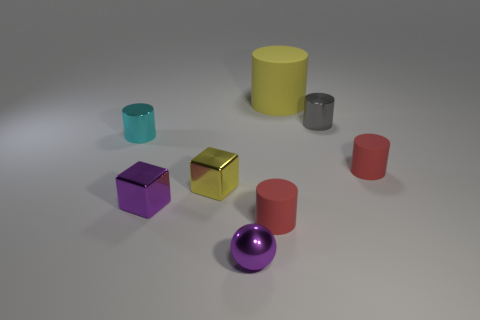There is a tiny metallic thing that is the same color as the small ball; what is its shape?
Provide a short and direct response. Cube. What is the material of the cyan cylinder?
Keep it short and to the point. Metal. There is a yellow object that is to the right of the tiny sphere; what size is it?
Offer a terse response. Large. How many big red matte things have the same shape as the gray metal thing?
Offer a terse response. 0. The yellow object that is the same material as the small gray thing is what shape?
Your answer should be very brief. Cube. What number of yellow objects are shiny cubes or large metal things?
Offer a terse response. 1. Are there any tiny gray metallic cylinders to the right of the tiny gray shiny thing?
Your response must be concise. No. There is a purple metallic object that is left of the tiny yellow metal object; does it have the same shape as the tiny purple object right of the small purple block?
Ensure brevity in your answer.  No. There is another large object that is the same shape as the cyan shiny thing; what is its material?
Make the answer very short. Rubber. What number of spheres are either blue objects or tiny yellow objects?
Offer a very short reply. 0. 